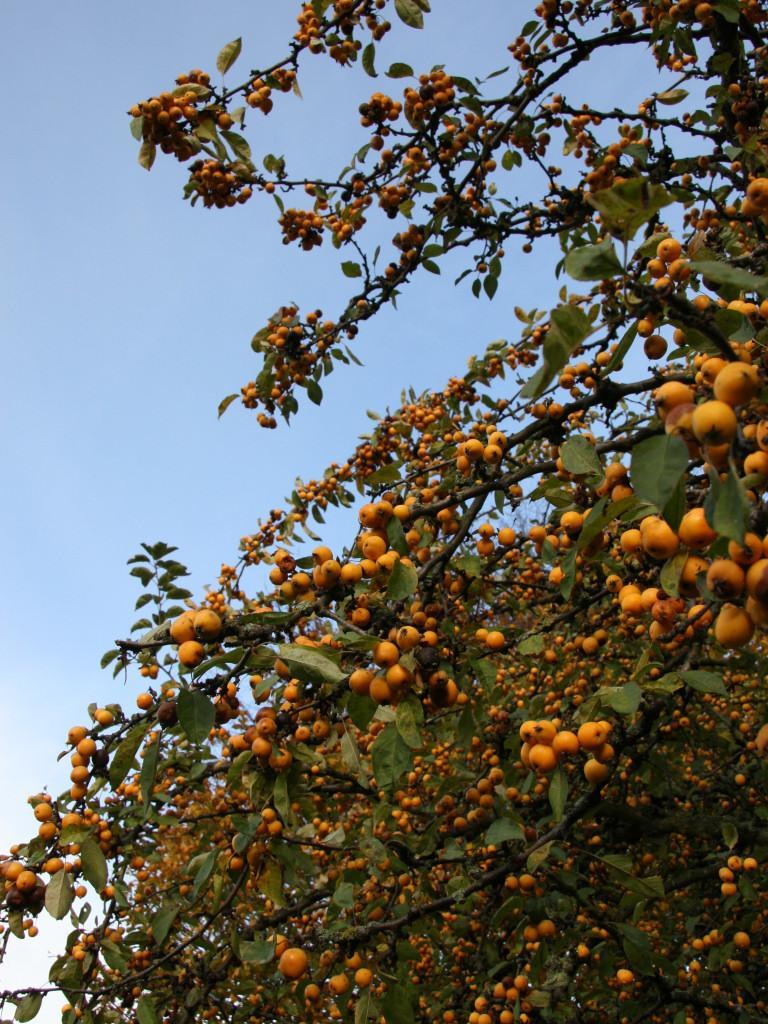How would you summarize this image in a sentence or two? In this image, we can see a branch contains leaves and fruits. In the background of the image, there is a sky. 